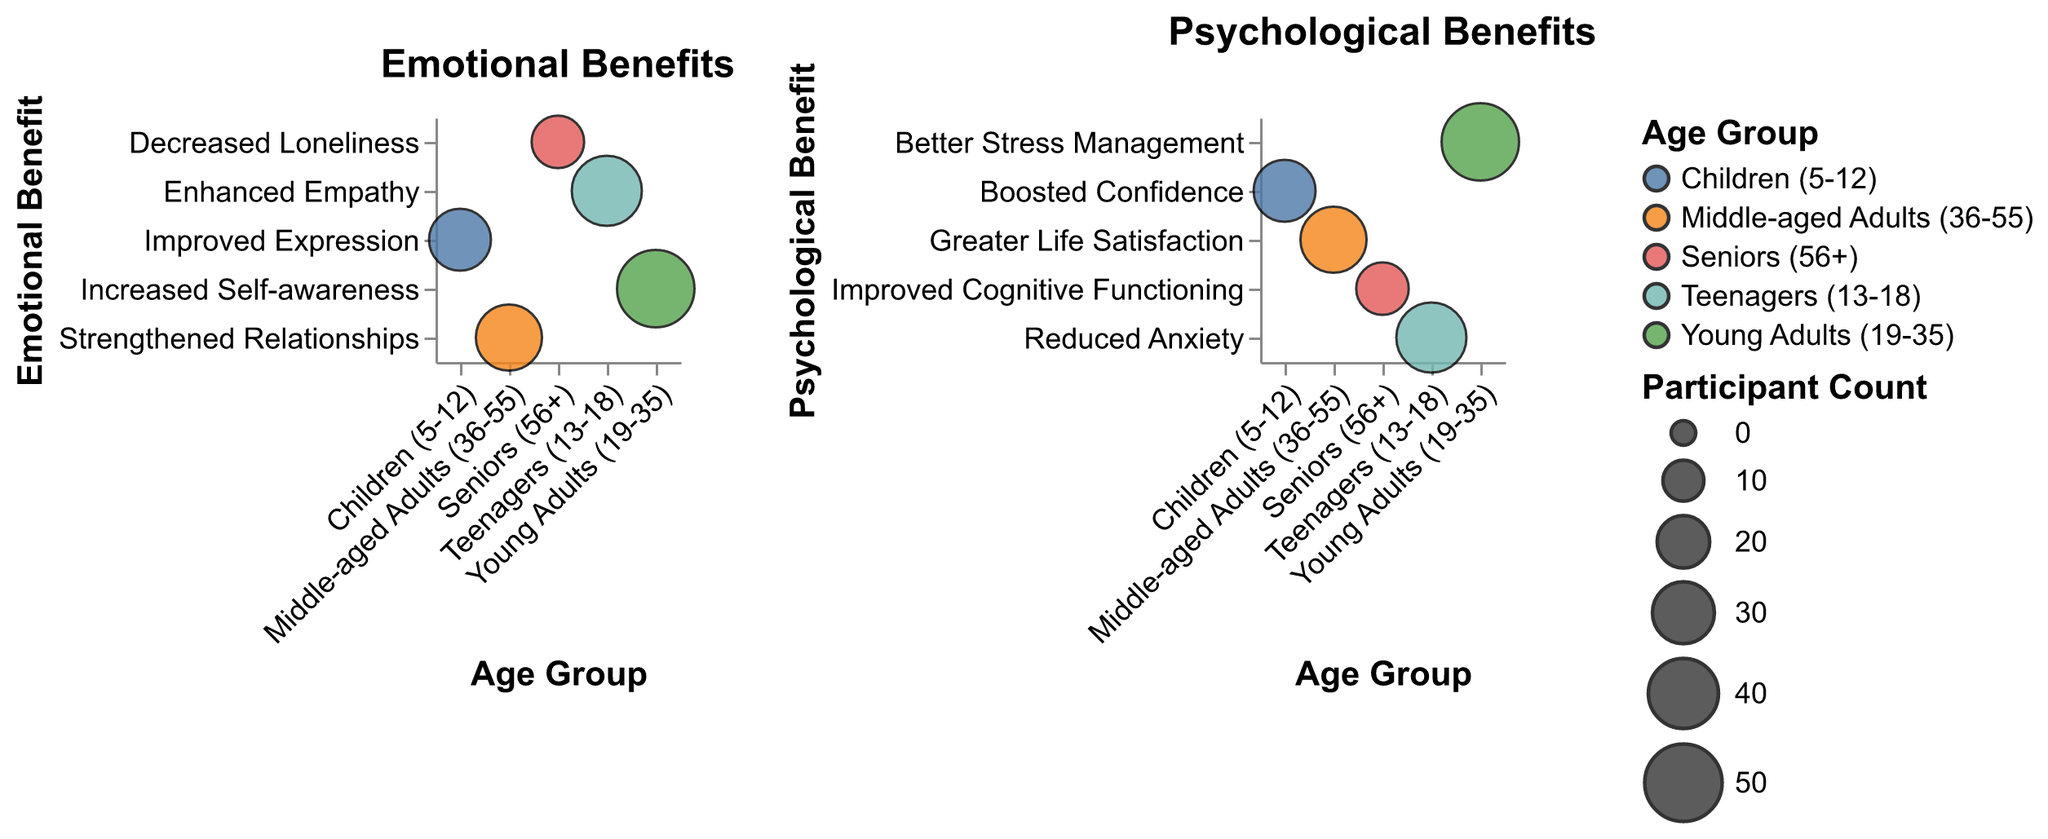What is the emotional benefit for children (5-12) in Playback Theatre? The emotional benefit for children (5-12) is represented by a specific label on the y-axis of the first subplot. By matching the age group on the x-axis to the corresponding label on the y-axis, we find the answer.
Answer: Improved Expression Which age group has the highest participant count in the Playback Theatre study? By looking at the size of the bubbles, the largest one indicates the age group with the highest participant count. The largest bubble can be found under the Young Adults (19-35) group.
Answer: Young Adults (19-35) What are the psychological benefits for middle-aged adults (36-55)? The psychological benefits for each age group are shown in the second subplot. By finding 'Middle-aged Adults (36-55)' on the x-axis and checking the corresponding y-axis value, we can determine the answer.
Answer: Greater Life Satisfaction How does the participant count compare between seniors (56+) and teenagers (13-18)? The participant counts are represented by the sizes of the bubbles. The size of the bubble for teenagers (40) is larger than that for seniors (20), indicating that teenagers have a greater participant count.
Answer: Teenagers (13-18) have more participants than seniors (56+) What is the difference in participant count between the group with the highest and the group with the lowest number of participants? The group with the highest participant count is Young Adults (19-35) at 50 participants, and the group with the lowest is Seniors (56+) at 20 participants. Calculating the difference: 50 - 20 = 30.
Answer: 30 Which age group experiences the psychological benefit of improved cognitive functioning? By checking the labels on the y-axis of the second subplot, we identify the age group corresponding to 'Improved Cognitive Functioning'. It matches with 'Seniors (56+).'
Answer: Seniors (56+) What emotional benefit do teenagers (13-18) gain from Playback Theatre? Checking the first subplot's y-axis for the corresponding value for 'Teenagers (13-18)', we find 'Enhanced Empathy' as the emotional benefit for this age group.
Answer: Enhanced Empathy Which emotional benefit has the largest bubble size indicative of the highest participant count? Looking at the sizes of the bubbles in the first subplot, 'Increased Self-awareness' has the largest bubble, indicating the highest number of participants, which belongs to Young Adults (19-35).
Answer: Increased Self-awareness Do middle-aged adults (36-55) or children (5-12) have a higher participant count? Comparing the bubble sizes for 'Middle-aged Adults (36-55)' and 'Children (5-12)' across both subplots, 'Middle-aged Adults (36-55)' have a higher participant count with 35 compared to 'Children (5-12)' with 30.
Answer: Middle-aged Adults (36-55) 